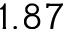Convert formula to latex. <formula><loc_0><loc_0><loc_500><loc_500>1 . 8 7</formula> 